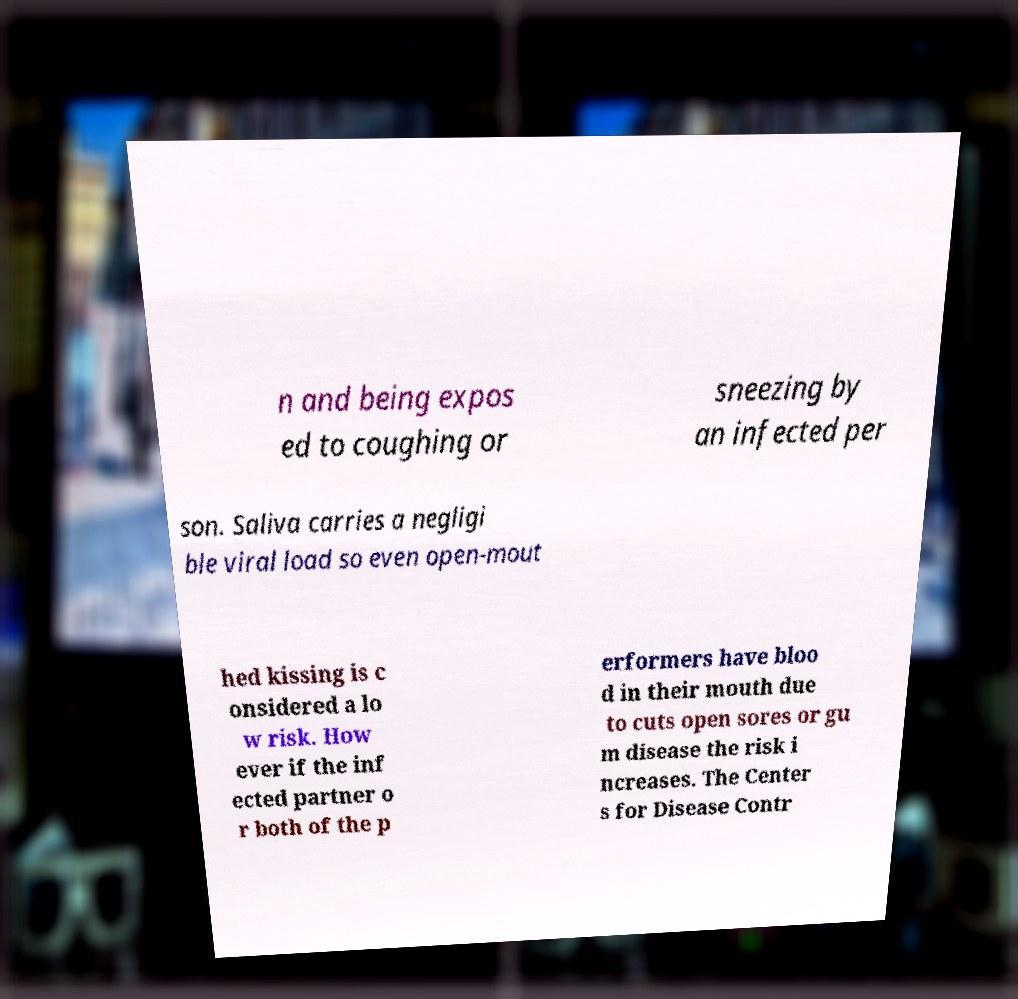What messages or text are displayed in this image? I need them in a readable, typed format. n and being expos ed to coughing or sneezing by an infected per son. Saliva carries a negligi ble viral load so even open-mout hed kissing is c onsidered a lo w risk. How ever if the inf ected partner o r both of the p erformers have bloo d in their mouth due to cuts open sores or gu m disease the risk i ncreases. The Center s for Disease Contr 